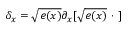Convert formula to latex. <formula><loc_0><loc_0><loc_500><loc_500>\delta _ { x } = \sqrt { e ( x ) } \partial _ { x } [ \sqrt { e ( x ) } \cdot ]</formula> 